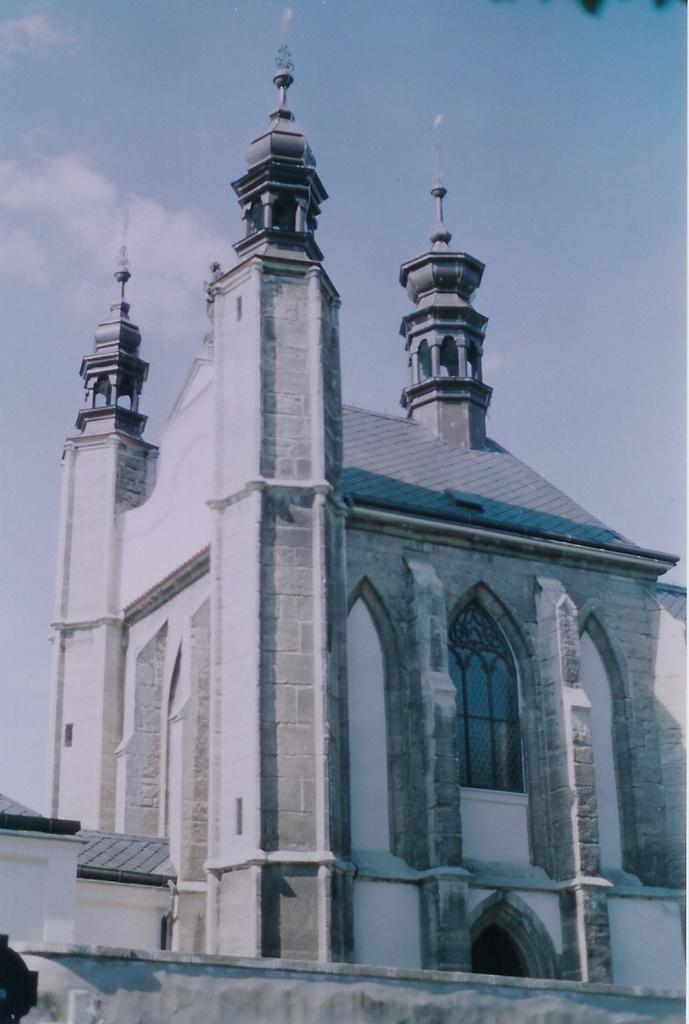What structure is present in the image? There is a building in the image. What is visible at the top of the image? The sky is visible at the top of the image. Where are the flowers arranged on a tray in the image? There are no flowers or trays present in the image. What type of corn is growing near the building in the image? There is no corn present in the image. 